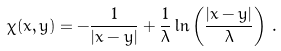Convert formula to latex. <formula><loc_0><loc_0><loc_500><loc_500>\chi ( x , y ) = - \frac { 1 } { | x - y | } + \frac { 1 } { \lambda } \ln \left ( \frac { | x - y | } { \lambda } \right ) \, .</formula> 